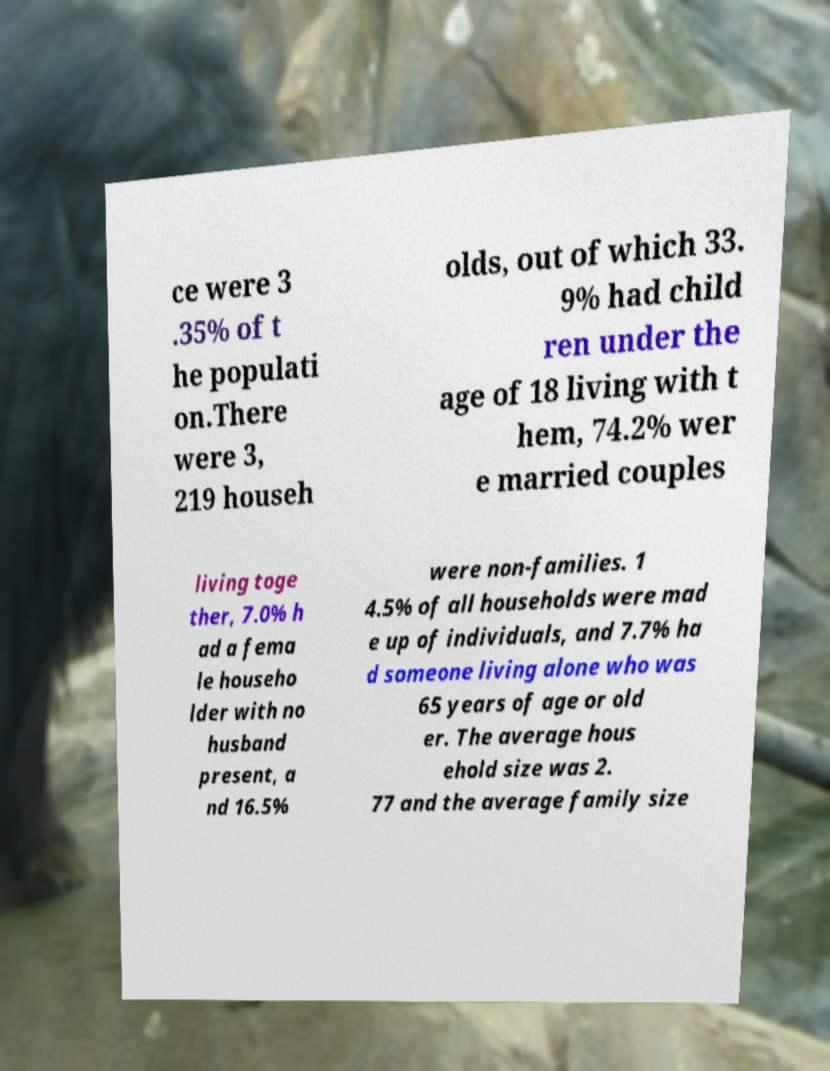Can you read and provide the text displayed in the image?This photo seems to have some interesting text. Can you extract and type it out for me? ce were 3 .35% of t he populati on.There were 3, 219 househ olds, out of which 33. 9% had child ren under the age of 18 living with t hem, 74.2% wer e married couples living toge ther, 7.0% h ad a fema le househo lder with no husband present, a nd 16.5% were non-families. 1 4.5% of all households were mad e up of individuals, and 7.7% ha d someone living alone who was 65 years of age or old er. The average hous ehold size was 2. 77 and the average family size 